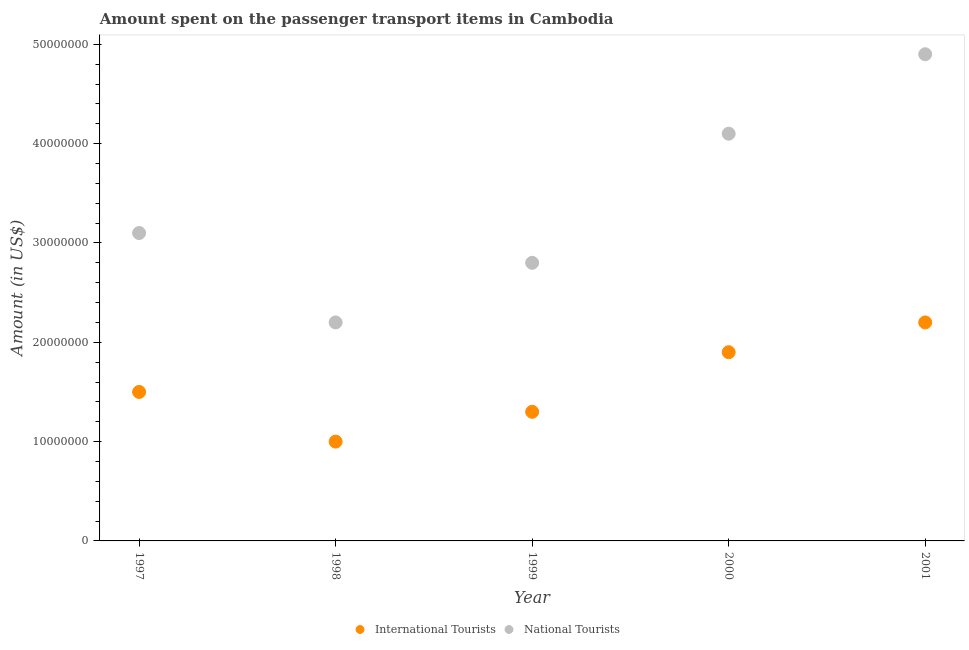What is the amount spent on transport items of international tourists in 1998?
Make the answer very short. 1.00e+07. Across all years, what is the maximum amount spent on transport items of national tourists?
Your answer should be compact. 4.90e+07. Across all years, what is the minimum amount spent on transport items of international tourists?
Make the answer very short. 1.00e+07. In which year was the amount spent on transport items of international tourists maximum?
Your answer should be compact. 2001. What is the total amount spent on transport items of national tourists in the graph?
Offer a very short reply. 1.71e+08. What is the difference between the amount spent on transport items of national tourists in 1997 and that in 1998?
Keep it short and to the point. 9.00e+06. What is the difference between the amount spent on transport items of national tourists in 2001 and the amount spent on transport items of international tourists in 1999?
Your answer should be very brief. 3.60e+07. What is the average amount spent on transport items of international tourists per year?
Offer a terse response. 1.58e+07. In the year 1997, what is the difference between the amount spent on transport items of national tourists and amount spent on transport items of international tourists?
Ensure brevity in your answer.  1.60e+07. What is the ratio of the amount spent on transport items of international tourists in 1999 to that in 2000?
Your response must be concise. 0.68. Is the amount spent on transport items of national tourists in 1997 less than that in 2000?
Provide a short and direct response. Yes. What is the difference between the highest and the lowest amount spent on transport items of international tourists?
Make the answer very short. 1.20e+07. Is the amount spent on transport items of international tourists strictly less than the amount spent on transport items of national tourists over the years?
Ensure brevity in your answer.  Yes. How many years are there in the graph?
Make the answer very short. 5. What is the difference between two consecutive major ticks on the Y-axis?
Give a very brief answer. 1.00e+07. Does the graph contain any zero values?
Give a very brief answer. No. Does the graph contain grids?
Offer a very short reply. No. Where does the legend appear in the graph?
Your answer should be compact. Bottom center. How many legend labels are there?
Your answer should be compact. 2. What is the title of the graph?
Your response must be concise. Amount spent on the passenger transport items in Cambodia. Does "Travel services" appear as one of the legend labels in the graph?
Ensure brevity in your answer.  No. What is the Amount (in US$) in International Tourists in 1997?
Ensure brevity in your answer.  1.50e+07. What is the Amount (in US$) of National Tourists in 1997?
Your answer should be compact. 3.10e+07. What is the Amount (in US$) in National Tourists in 1998?
Offer a very short reply. 2.20e+07. What is the Amount (in US$) of International Tourists in 1999?
Give a very brief answer. 1.30e+07. What is the Amount (in US$) in National Tourists in 1999?
Provide a short and direct response. 2.80e+07. What is the Amount (in US$) in International Tourists in 2000?
Your answer should be compact. 1.90e+07. What is the Amount (in US$) in National Tourists in 2000?
Your answer should be very brief. 4.10e+07. What is the Amount (in US$) of International Tourists in 2001?
Offer a terse response. 2.20e+07. What is the Amount (in US$) in National Tourists in 2001?
Provide a succinct answer. 4.90e+07. Across all years, what is the maximum Amount (in US$) of International Tourists?
Your answer should be very brief. 2.20e+07. Across all years, what is the maximum Amount (in US$) in National Tourists?
Ensure brevity in your answer.  4.90e+07. Across all years, what is the minimum Amount (in US$) of International Tourists?
Provide a short and direct response. 1.00e+07. Across all years, what is the minimum Amount (in US$) in National Tourists?
Keep it short and to the point. 2.20e+07. What is the total Amount (in US$) of International Tourists in the graph?
Keep it short and to the point. 7.90e+07. What is the total Amount (in US$) of National Tourists in the graph?
Make the answer very short. 1.71e+08. What is the difference between the Amount (in US$) in International Tourists in 1997 and that in 1998?
Make the answer very short. 5.00e+06. What is the difference between the Amount (in US$) in National Tourists in 1997 and that in 1998?
Provide a short and direct response. 9.00e+06. What is the difference between the Amount (in US$) of National Tourists in 1997 and that in 2000?
Provide a short and direct response. -1.00e+07. What is the difference between the Amount (in US$) in International Tourists in 1997 and that in 2001?
Provide a succinct answer. -7.00e+06. What is the difference between the Amount (in US$) of National Tourists in 1997 and that in 2001?
Your answer should be compact. -1.80e+07. What is the difference between the Amount (in US$) in National Tourists in 1998 and that in 1999?
Give a very brief answer. -6.00e+06. What is the difference between the Amount (in US$) in International Tourists in 1998 and that in 2000?
Your answer should be compact. -9.00e+06. What is the difference between the Amount (in US$) of National Tourists in 1998 and that in 2000?
Offer a terse response. -1.90e+07. What is the difference between the Amount (in US$) of International Tourists in 1998 and that in 2001?
Offer a very short reply. -1.20e+07. What is the difference between the Amount (in US$) of National Tourists in 1998 and that in 2001?
Provide a succinct answer. -2.70e+07. What is the difference between the Amount (in US$) in International Tourists in 1999 and that in 2000?
Keep it short and to the point. -6.00e+06. What is the difference between the Amount (in US$) of National Tourists in 1999 and that in 2000?
Make the answer very short. -1.30e+07. What is the difference between the Amount (in US$) in International Tourists in 1999 and that in 2001?
Keep it short and to the point. -9.00e+06. What is the difference between the Amount (in US$) in National Tourists in 1999 and that in 2001?
Your answer should be compact. -2.10e+07. What is the difference between the Amount (in US$) of International Tourists in 2000 and that in 2001?
Make the answer very short. -3.00e+06. What is the difference between the Amount (in US$) in National Tourists in 2000 and that in 2001?
Give a very brief answer. -8.00e+06. What is the difference between the Amount (in US$) in International Tourists in 1997 and the Amount (in US$) in National Tourists in 1998?
Make the answer very short. -7.00e+06. What is the difference between the Amount (in US$) of International Tourists in 1997 and the Amount (in US$) of National Tourists in 1999?
Make the answer very short. -1.30e+07. What is the difference between the Amount (in US$) in International Tourists in 1997 and the Amount (in US$) in National Tourists in 2000?
Keep it short and to the point. -2.60e+07. What is the difference between the Amount (in US$) of International Tourists in 1997 and the Amount (in US$) of National Tourists in 2001?
Offer a very short reply. -3.40e+07. What is the difference between the Amount (in US$) in International Tourists in 1998 and the Amount (in US$) in National Tourists in 1999?
Your response must be concise. -1.80e+07. What is the difference between the Amount (in US$) in International Tourists in 1998 and the Amount (in US$) in National Tourists in 2000?
Offer a very short reply. -3.10e+07. What is the difference between the Amount (in US$) in International Tourists in 1998 and the Amount (in US$) in National Tourists in 2001?
Your response must be concise. -3.90e+07. What is the difference between the Amount (in US$) in International Tourists in 1999 and the Amount (in US$) in National Tourists in 2000?
Your answer should be very brief. -2.80e+07. What is the difference between the Amount (in US$) of International Tourists in 1999 and the Amount (in US$) of National Tourists in 2001?
Your answer should be compact. -3.60e+07. What is the difference between the Amount (in US$) in International Tourists in 2000 and the Amount (in US$) in National Tourists in 2001?
Your answer should be compact. -3.00e+07. What is the average Amount (in US$) of International Tourists per year?
Give a very brief answer. 1.58e+07. What is the average Amount (in US$) of National Tourists per year?
Your answer should be compact. 3.42e+07. In the year 1997, what is the difference between the Amount (in US$) of International Tourists and Amount (in US$) of National Tourists?
Offer a very short reply. -1.60e+07. In the year 1998, what is the difference between the Amount (in US$) of International Tourists and Amount (in US$) of National Tourists?
Your answer should be compact. -1.20e+07. In the year 1999, what is the difference between the Amount (in US$) of International Tourists and Amount (in US$) of National Tourists?
Provide a short and direct response. -1.50e+07. In the year 2000, what is the difference between the Amount (in US$) of International Tourists and Amount (in US$) of National Tourists?
Provide a short and direct response. -2.20e+07. In the year 2001, what is the difference between the Amount (in US$) of International Tourists and Amount (in US$) of National Tourists?
Keep it short and to the point. -2.70e+07. What is the ratio of the Amount (in US$) in National Tourists in 1997 to that in 1998?
Give a very brief answer. 1.41. What is the ratio of the Amount (in US$) of International Tourists in 1997 to that in 1999?
Your response must be concise. 1.15. What is the ratio of the Amount (in US$) of National Tourists in 1997 to that in 1999?
Offer a very short reply. 1.11. What is the ratio of the Amount (in US$) in International Tourists in 1997 to that in 2000?
Offer a very short reply. 0.79. What is the ratio of the Amount (in US$) in National Tourists in 1997 to that in 2000?
Your response must be concise. 0.76. What is the ratio of the Amount (in US$) in International Tourists in 1997 to that in 2001?
Provide a short and direct response. 0.68. What is the ratio of the Amount (in US$) of National Tourists in 1997 to that in 2001?
Ensure brevity in your answer.  0.63. What is the ratio of the Amount (in US$) in International Tourists in 1998 to that in 1999?
Offer a very short reply. 0.77. What is the ratio of the Amount (in US$) of National Tourists in 1998 to that in 1999?
Ensure brevity in your answer.  0.79. What is the ratio of the Amount (in US$) of International Tourists in 1998 to that in 2000?
Ensure brevity in your answer.  0.53. What is the ratio of the Amount (in US$) of National Tourists in 1998 to that in 2000?
Provide a short and direct response. 0.54. What is the ratio of the Amount (in US$) of International Tourists in 1998 to that in 2001?
Keep it short and to the point. 0.45. What is the ratio of the Amount (in US$) of National Tourists in 1998 to that in 2001?
Give a very brief answer. 0.45. What is the ratio of the Amount (in US$) in International Tourists in 1999 to that in 2000?
Your response must be concise. 0.68. What is the ratio of the Amount (in US$) of National Tourists in 1999 to that in 2000?
Ensure brevity in your answer.  0.68. What is the ratio of the Amount (in US$) of International Tourists in 1999 to that in 2001?
Offer a very short reply. 0.59. What is the ratio of the Amount (in US$) in International Tourists in 2000 to that in 2001?
Your answer should be very brief. 0.86. What is the ratio of the Amount (in US$) of National Tourists in 2000 to that in 2001?
Make the answer very short. 0.84. What is the difference between the highest and the lowest Amount (in US$) of National Tourists?
Ensure brevity in your answer.  2.70e+07. 